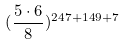<formula> <loc_0><loc_0><loc_500><loc_500>( \frac { 5 \cdot 6 } { 8 } ) ^ { 2 4 7 + 1 4 9 + 7 }</formula> 